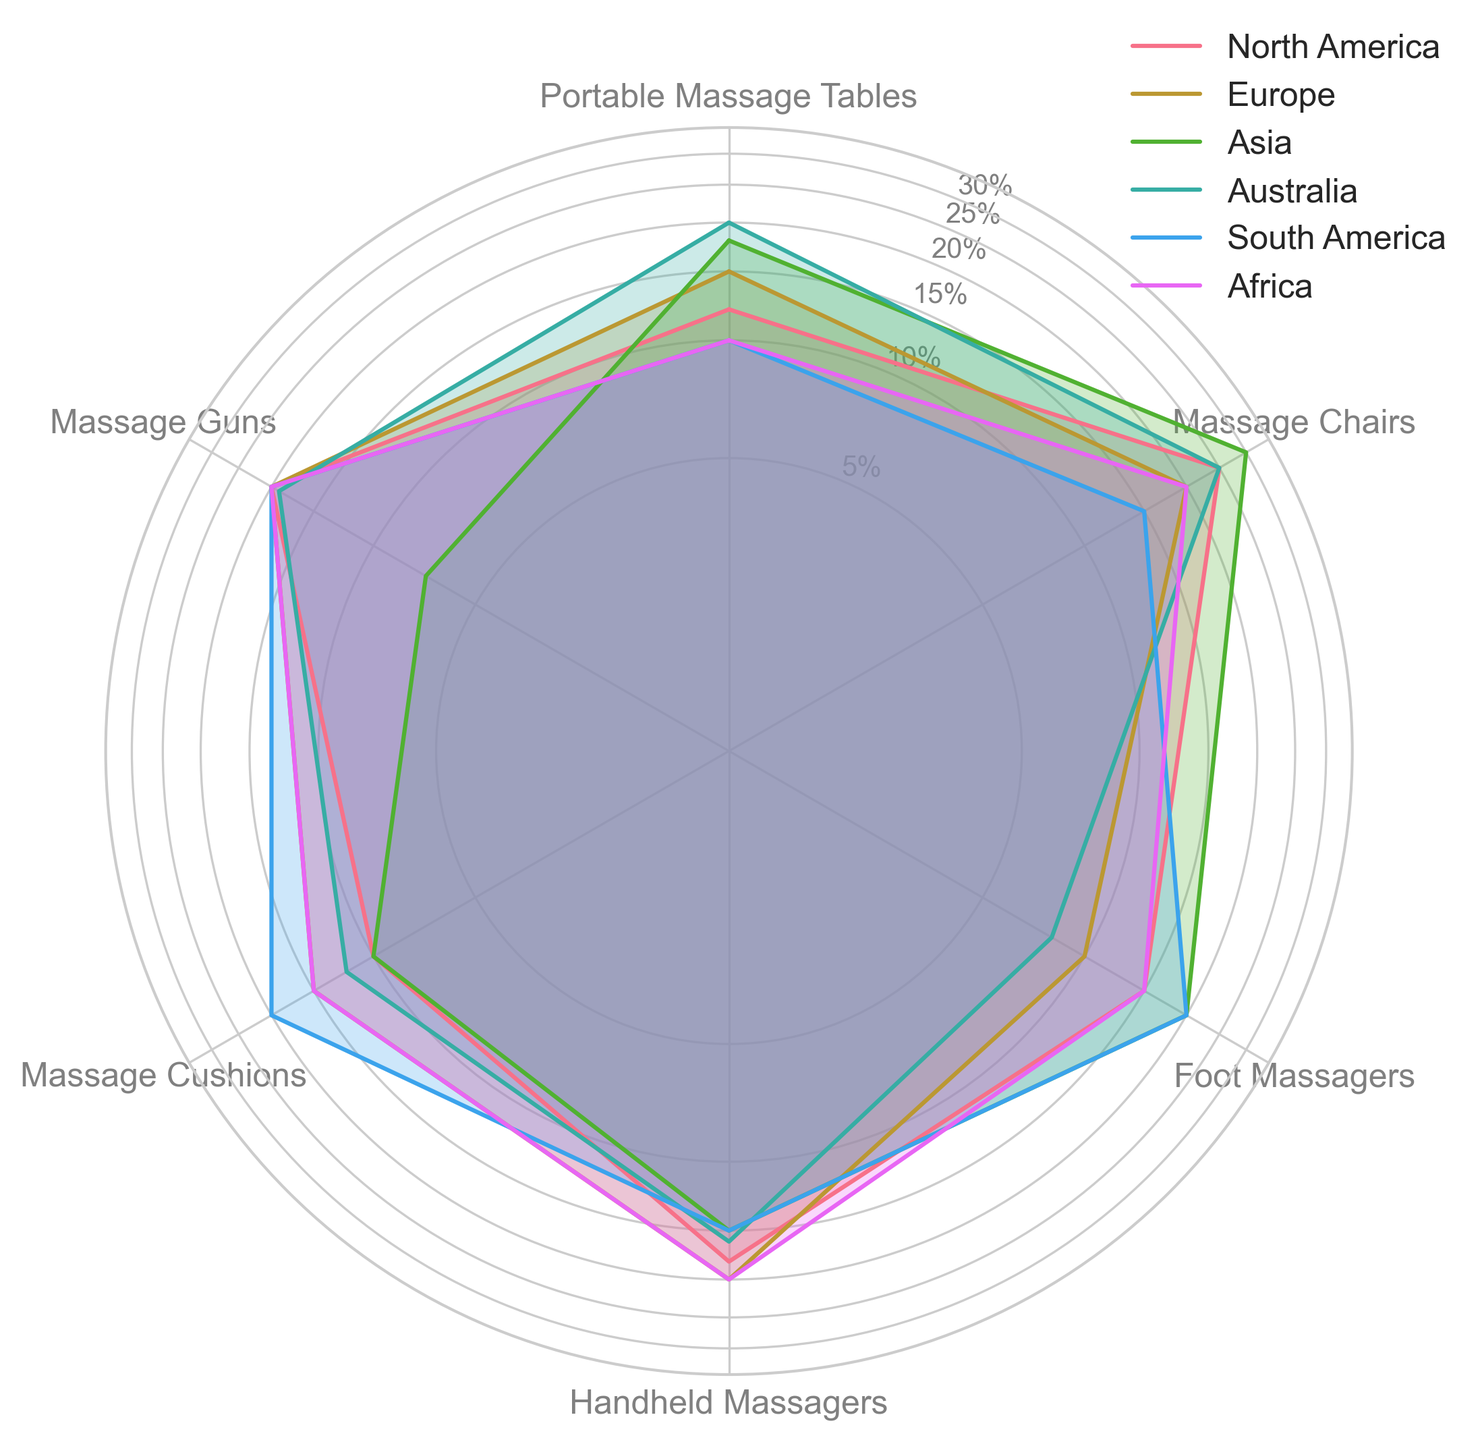Which region has the highest percentage demand for Massage Chairs? In the radar chart, we observe that the line or area corresponding to Asia extends farthest from the center for Massage Chairs.
Answer: Asia What is the combined percentage demand for Foot Massagers and Massage Guns in North America? From the radar chart, North America's demand for Foot Massagers and Massage Guns are 15% and 20%, respectively. Their sum is 15 + 20.
Answer: 35% Which region shows an equal percentage demand for both Handheld Massagers and Massage Guns? Looking at the radar chart, both Handheld Massagers and Massage Guns in Europe, South America, and Africa are represented by equal extensions from the center, each at 20%.
Answer: Europe, South America, Africa Compare the demand for Massage Cushions between Asia and North America. Which region has a higher percentage, and by how much? The demand for Massage Cushions in Asia is 10%, while in North America, it is 10%. Since both percentages are equal, there is no higher demand.
Answer: Same What is the average percentage demand for Portable Massage Tables across all regions? The percentages for Portable Massage Tables in all regions are: 12, 15, 18, 20, 10, 10. Summing these and dividing by the number of regions: (12 + 15 + 18 + 20 + 10 + 10) / 6 = 85 / 6
Answer: 14.17% Among all regions, which one shows the least demand for Foot Massagers? The radar chart shows that the least extended line or area for Foot Massagers corresponds to Australia, with 8%.
Answer: Australia How does the demand for Massage Guns in North America compare to that in Asia? North America's demand for Massage Guns is 20%, while Asia's is 7%. Thus, North America's demand is higher by 20 - 7.
Answer: 13% What's the range of percentage demand for Massage Cushions across all regions? The highest percentage demand for Massage Cushions is 20% (in South America), and the lowest is 10% (in North America and Asia). The range is 20 - 10.
Answer: 10% If you total the percentage demand for all six types of massage equipment in Europe, what is the value? The percentages for each type in Europe are: 15, 20, 10, 20, 15, 20. Summing these: 15 + 20 + 10 + 20 + 15 + 20.
Answer: 100% 